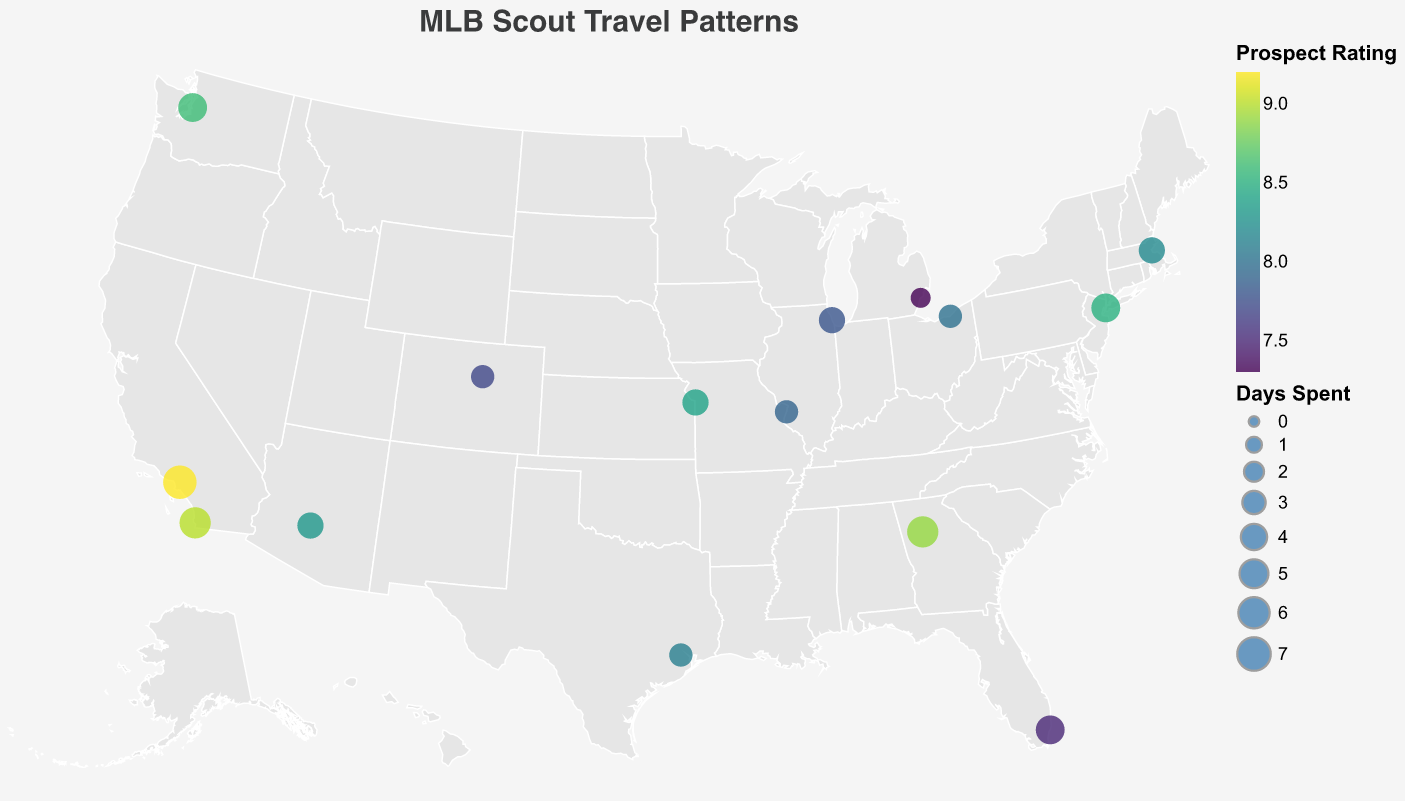What is the title of the figure? The title is a textual element at the top of the figure, used to provide an overview of the content. In this case, it reads "MLB Scout Travel Patterns".
Answer: MLB Scout Travel Patterns Which city has the highest number of days spent by scouts? Look for the largest circle on the map, which corresponds to the highest value of the "DaysSpent" field. According to the data, the largest circle represents Los Angeles, where 7 days were spent.
Answer: Los Angeles How are the cities color-coded? Examine the color legend for the figure, which shows that cities are color-coded based on "Prospect Rating" with a color scheme ranging from low to high values.
Answer: Based on the Prospect Rating Which city has the highest prospect rating? Refer to the color of the circles and the legend indicating prospect ratings. The circle with the deepest color corresponds to Los Angeles, which has the highest prospect rating of 9.2.
Answer: Los Angeles What is the average Prospect Rating for cities where scouts spent more than 4 days? First, identify the cities where "DaysSpent" is more than 4: New York, Los Angeles, Atlanta, Miami, Seattle, and San Diego. Their prospect ratings are 8.5, 9.2, 8.9, 7.5, 8.6, and 9.0. Calculate the average: (8.5 + 9.2 + 8.9 + 7.5 + 8.6 + 9.0) / 6 = 8.62.
Answer: 8.62 How many cities have a Prospect Rating higher than 8.5? Look at the prospect ratings and count the number of cities with ratings greater than 8.5. These are Los Angeles (9.2), Atlanta (8.9), Seattle (8.6), and San Diego (9.0), making a total of 4 cities.
Answer: 4 Which city appears to be visited the least based on the number of days spent? Identify the smallest circle on the map, which corresponds to the lowest "DaysSpent" value. According to the data, Detroit, with 2 days spent, is the smallest circle.
Answer: Detroit What is the total number of days spent by scouts in all cities combined? Sum up the "DaysSpent" values for all cities: 5 + 7 + 4 + 3 + 6 + 5 + 4 + 3 + 5 + 4 + 3 + 6 + 2 + 3 + 4 = 64.
Answer: 64 Which city in the Midwest region has the highest Prospect Rating? Identify cities in the Midwest region (Chicago, Detroit, Cleveland, St. Louis, Kansas City). Compare their Prospect Ratings: Chicago (7.8), Detroit (7.3), Cleveland (8.0), St. Louis (7.9), Kansas City (8.4). Kansas City has the highest with 8.4.
Answer: Kansas City 